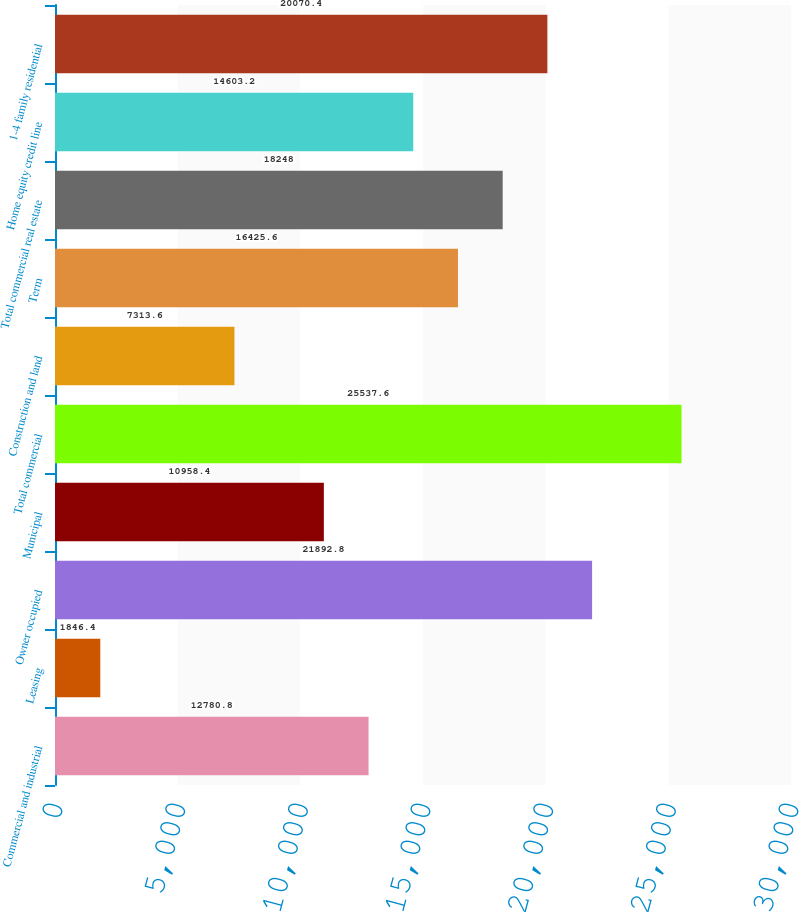Convert chart. <chart><loc_0><loc_0><loc_500><loc_500><bar_chart><fcel>Commercial and industrial<fcel>Leasing<fcel>Owner occupied<fcel>Municipal<fcel>Total commercial<fcel>Construction and land<fcel>Term<fcel>Total commercial real estate<fcel>Home equity credit line<fcel>1-4 family residential<nl><fcel>12780.8<fcel>1846.4<fcel>21892.8<fcel>10958.4<fcel>25537.6<fcel>7313.6<fcel>16425.6<fcel>18248<fcel>14603.2<fcel>20070.4<nl></chart> 